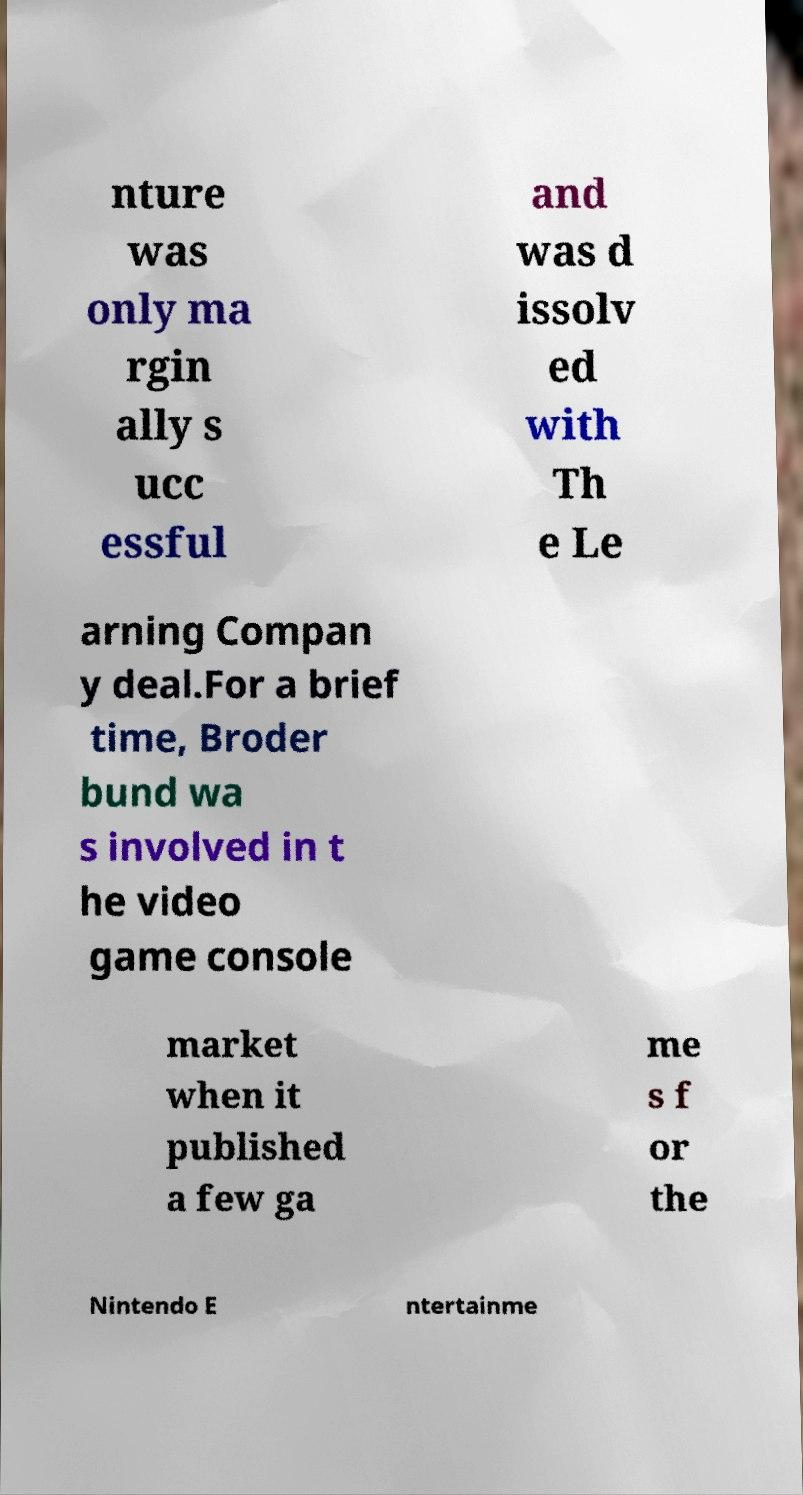Could you extract and type out the text from this image? nture was only ma rgin ally s ucc essful and was d issolv ed with Th e Le arning Compan y deal.For a brief time, Broder bund wa s involved in t he video game console market when it published a few ga me s f or the Nintendo E ntertainme 